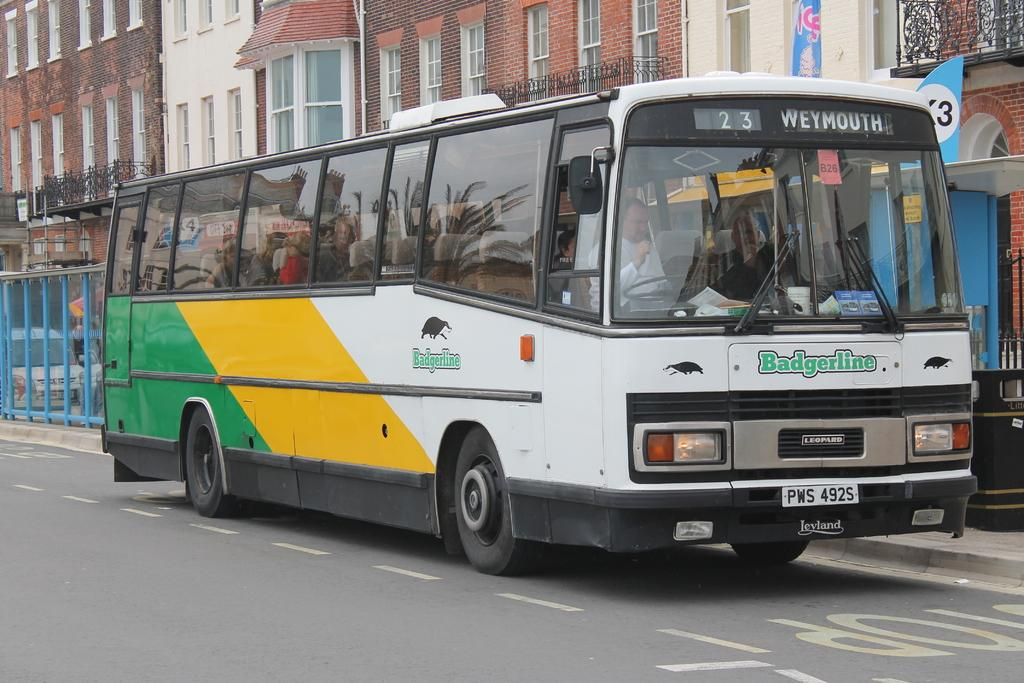What is the main subject of the image? There is a bus in the image. Where is the bus located? The bus is on the road. What can be seen in the background of the image? There are buildings with windows in the image. What flavor of ice cream is being served in the jail in the image? There is no jail or ice cream present in the image; it features a bus on the road and buildings with windows in the background. 